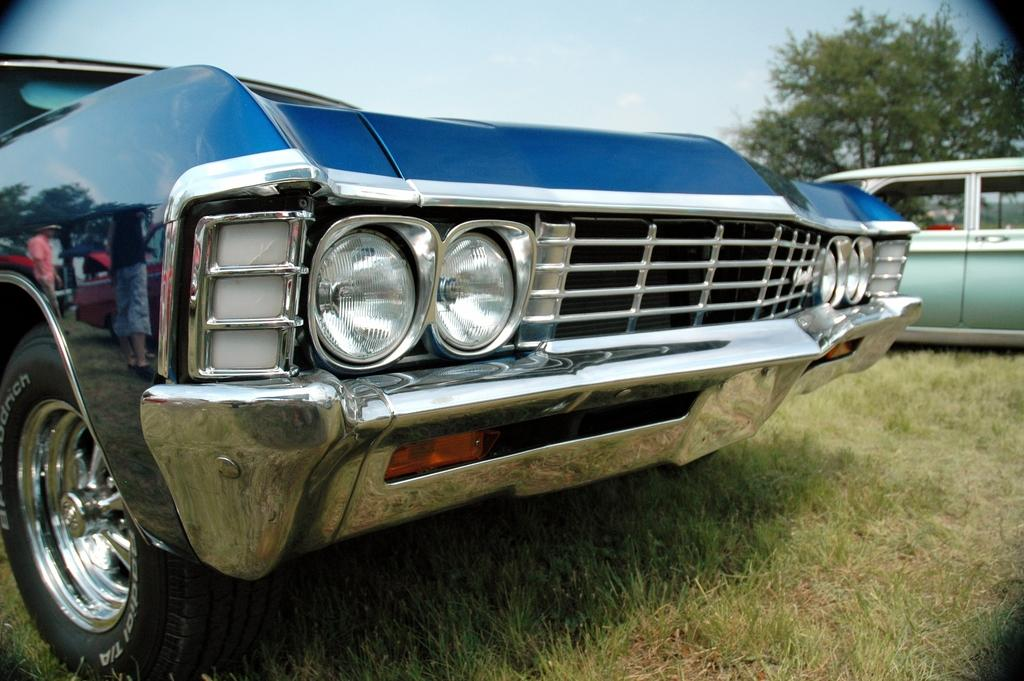What types of objects are on the ground in the image? There are vehicles on the ground in the image. What can be seen in the distance in the image? There are trees visible in the background of the image. How many pigs are visible in the image? There are no pigs present in the image. What type of footwear is being worn by the ducks in the image? There are no ducks present in the image, so it is not possible to determine what type of footwear they might be wearing. 